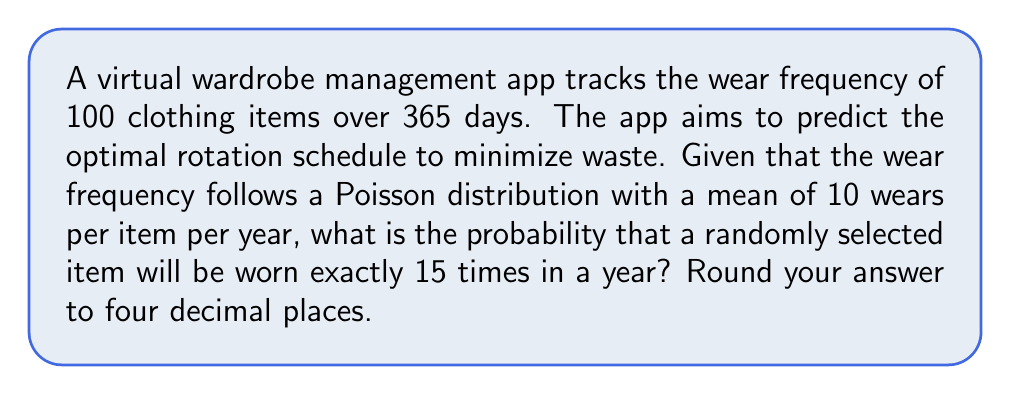Teach me how to tackle this problem. To solve this problem, we'll use the Poisson distribution formula:

$$P(X = k) = \frac{e^{-\lambda} \lambda^k}{k!}$$

Where:
$\lambda$ = mean number of occurrences
$k$ = number of occurrences we're interested in
$e$ = Euler's number (approximately 2.71828)

Given:
$\lambda = 10$ (mean wears per item per year)
$k = 15$ (wears we're interested in)

Step 1: Plug the values into the Poisson distribution formula:

$$P(X = 15) = \frac{e^{-10} 10^{15}}{15!}$$

Step 2: Calculate $e^{-10}$:
$e^{-10} \approx 0.0000454$

Step 3: Calculate $10^{15}$:
$10^{15} = 1,000,000,000,000,000$

Step 4: Calculate 15!:
$15! = 1,307,674,368,000$

Step 5: Plug these values into the equation:

$$P(X = 15) = \frac{0.0000454 \times 1,000,000,000,000,000}{1,307,674,368,000}$$

Step 6: Simplify:

$$P(X = 15) \approx 0.0347$$

Step 7: Round to four decimal places:

$$P(X = 15) \approx 0.0347$$
Answer: 0.0347 